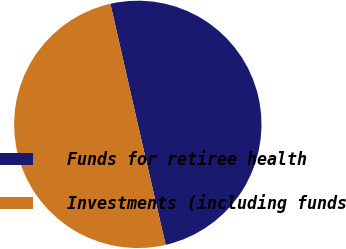Convert chart to OTSL. <chart><loc_0><loc_0><loc_500><loc_500><pie_chart><fcel>Funds for retiree health<fcel>Investments (including funds<nl><fcel>49.94%<fcel>50.06%<nl></chart> 